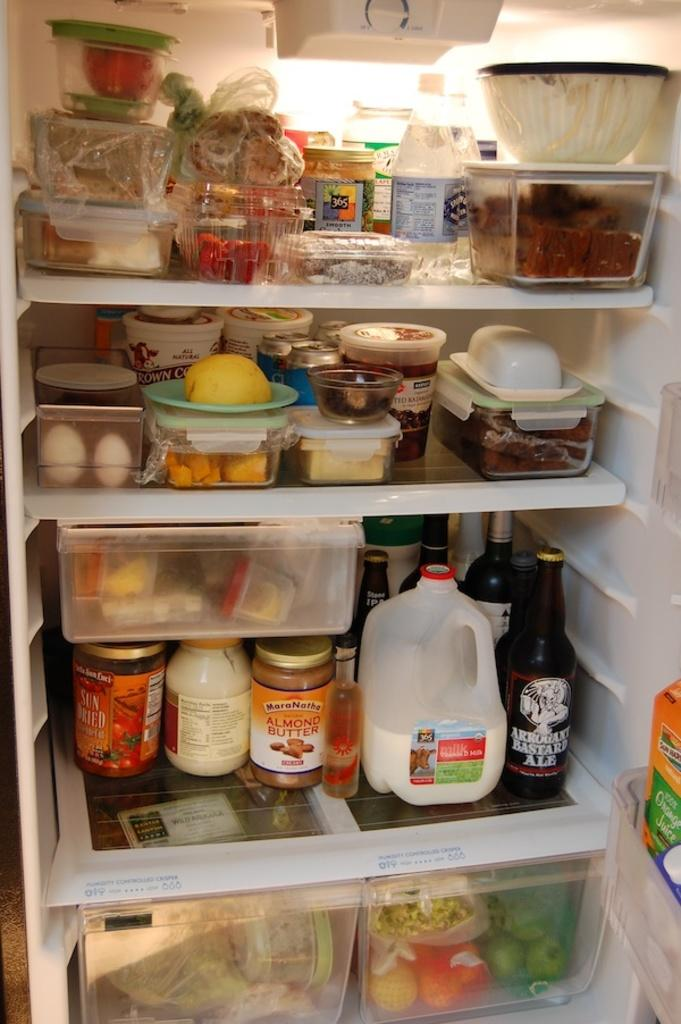Provide a one-sentence caption for the provided image. A refridgerator that has milk on the bottom with a bottle of Arrogant Bastard Ale next to it. 